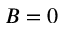<formula> <loc_0><loc_0><loc_500><loc_500>B = 0</formula> 